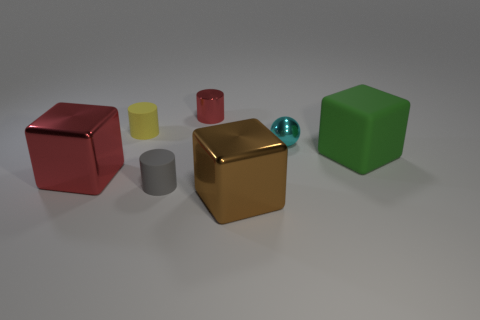Add 1 tiny matte cylinders. How many objects exist? 8 Subtract all balls. How many objects are left? 6 Add 5 cylinders. How many cylinders are left? 8 Add 7 matte objects. How many matte objects exist? 10 Subtract 0 gray blocks. How many objects are left? 7 Subtract all tiny shiny balls. Subtract all shiny cylinders. How many objects are left? 5 